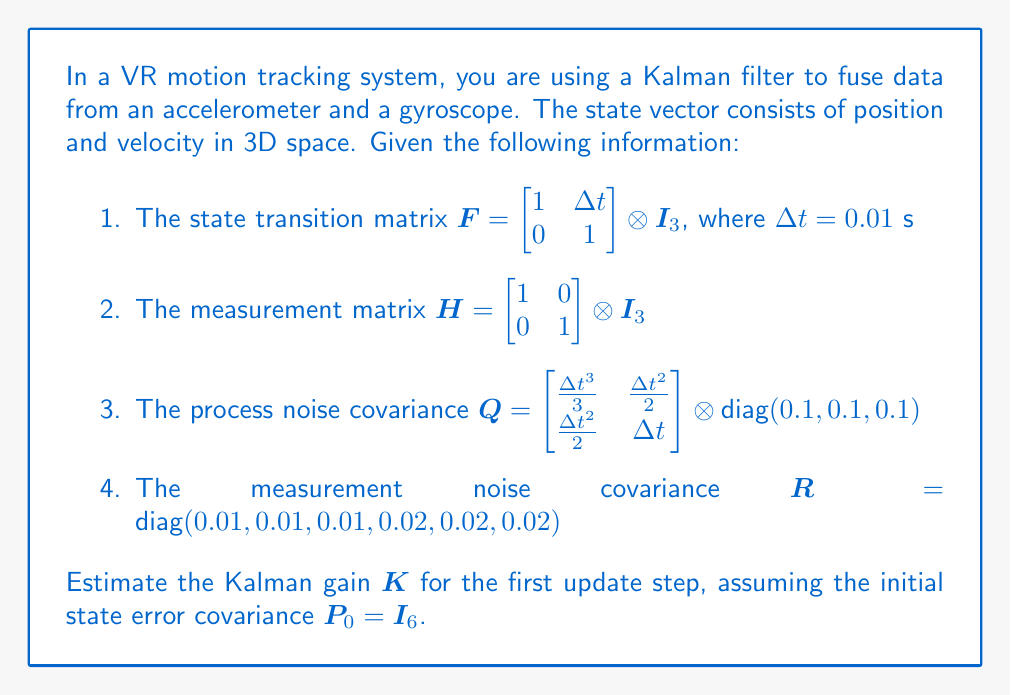Help me with this question. To estimate the Kalman gain $K$, we need to follow these steps:

1. Predict the state error covariance:
   $$P^- = FP_0F^T + Q$$

2. Calculate the innovation covariance:
   $$S = HP^-H^T + R$$

3. Compute the Kalman gain:
   $$K = P^-H^T S^{-1}$$

Let's go through each step:

1. Predict the state error covariance:
   $$P^- = FP_0F^T + Q$$
   
   Expanding this:
   $$P^- = \begin{bmatrix} 1 & 0.01 \\ 0 & 1 \end{bmatrix} \otimes I_3 \cdot I_6 \cdot \begin{bmatrix} 1 & 0 \\ 0.01 & 1 \end{bmatrix} \otimes I_3 + \begin{bmatrix} \frac{0.01^3}{3} & \frac{0.01^2}{2} \\ \frac{0.01^2}{2} & 0.01 \end{bmatrix} \otimes \text{diag}(0.1, 0.1, 0.1)$$
   
   $$P^- = \begin{bmatrix} 1.0001 & 0.01 \\ 0.01 & 1 \end{bmatrix} \otimes I_3 + \begin{bmatrix} 3.33 \times 10^{-7} & 5 \times 10^{-5} \\ 5 \times 10^{-5} & 0.001 \end{bmatrix} \otimes I_3$$
   
   $$P^- = \begin{bmatrix} 1.0001 & 0.01 \\ 0.01 & 1.001 \end{bmatrix} \otimes I_3$$

2. Calculate the innovation covariance:
   $$S = HP^-H^T + R$$
   
   $$S = \begin{bmatrix} 1 & 0 \\ 0 & 1 \end{bmatrix} \otimes I_3 \cdot \begin{bmatrix} 1.0001 & 0.01 \\ 0.01 & 1.001 \end{bmatrix} \otimes I_3 \cdot \begin{bmatrix} 1 & 0 \\ 0 & 1 \end{bmatrix} \otimes I_3 + \text{diag}(0.01, 0.01, 0.01, 0.02, 0.02, 0.02)$$
   
   $$S = \begin{bmatrix} 1.0001 & 0 \\ 0 & 1.001 \end{bmatrix} \otimes I_3 + \text{diag}(0.01, 0.01, 0.01, 0.02, 0.02, 0.02)$$
   
   $$S = \text{diag}(1.0101, 1.0101, 1.0101, 1.021, 1.021, 1.021)$$

3. Compute the Kalman gain:
   $$K = P^-H^T S^{-1}$$
   
   $$K = \begin{bmatrix} 1.0001 & 0.01 \\ 0.01 & 1.001 \end{bmatrix} \otimes I_3 \cdot \begin{bmatrix} 1 & 0 \\ 0 & 1 \end{bmatrix} \otimes I_3 \cdot \text{diag}(1/1.0101, 1/1.0101, 1/1.0101, 1/1.021, 1/1.021, 1/1.021)$$
   
   $$K = \begin{bmatrix} 1.0001 & 0.01 \\ 0.01 & 1.001 \end{bmatrix} \otimes I_3 \cdot \text{diag}(1/1.0101, 1/1.0101, 1/1.0101, 1/1.021, 1/1.021, 1/1.021)$$
   
   $$K = \begin{bmatrix} 0.9901 & 0 & 0 & 0.0098 & 0 & 0 \\ 0 & 0.9901 & 0 & 0 & 0.0098 & 0 \\ 0 & 0 & 0.9901 & 0 & 0 & 0.0098 \\ 0.0099 & 0 & 0 & 0.9805 & 0 & 0 \\ 0 & 0.0099 & 0 & 0 & 0.9805 & 0 \\ 0 & 0 & 0.0099 & 0 & 0 & 0.9805 \end{bmatrix}$$
Answer: $$K = \begin{bmatrix} 0.9901 & 0 & 0 & 0.0098 & 0 & 0 \\ 0 & 0.9901 & 0 & 0 & 0.0098 & 0 \\ 0 & 0 & 0.9901 & 0 & 0 & 0.0098 \\ 0.0099 & 0 & 0 & 0.9805 & 0 & 0 \\ 0 & 0.0099 & 0 & 0 & 0.9805 & 0 \\ 0 & 0 & 0.0099 & 0 & 0 & 0.9805 \end{bmatrix}$$ 